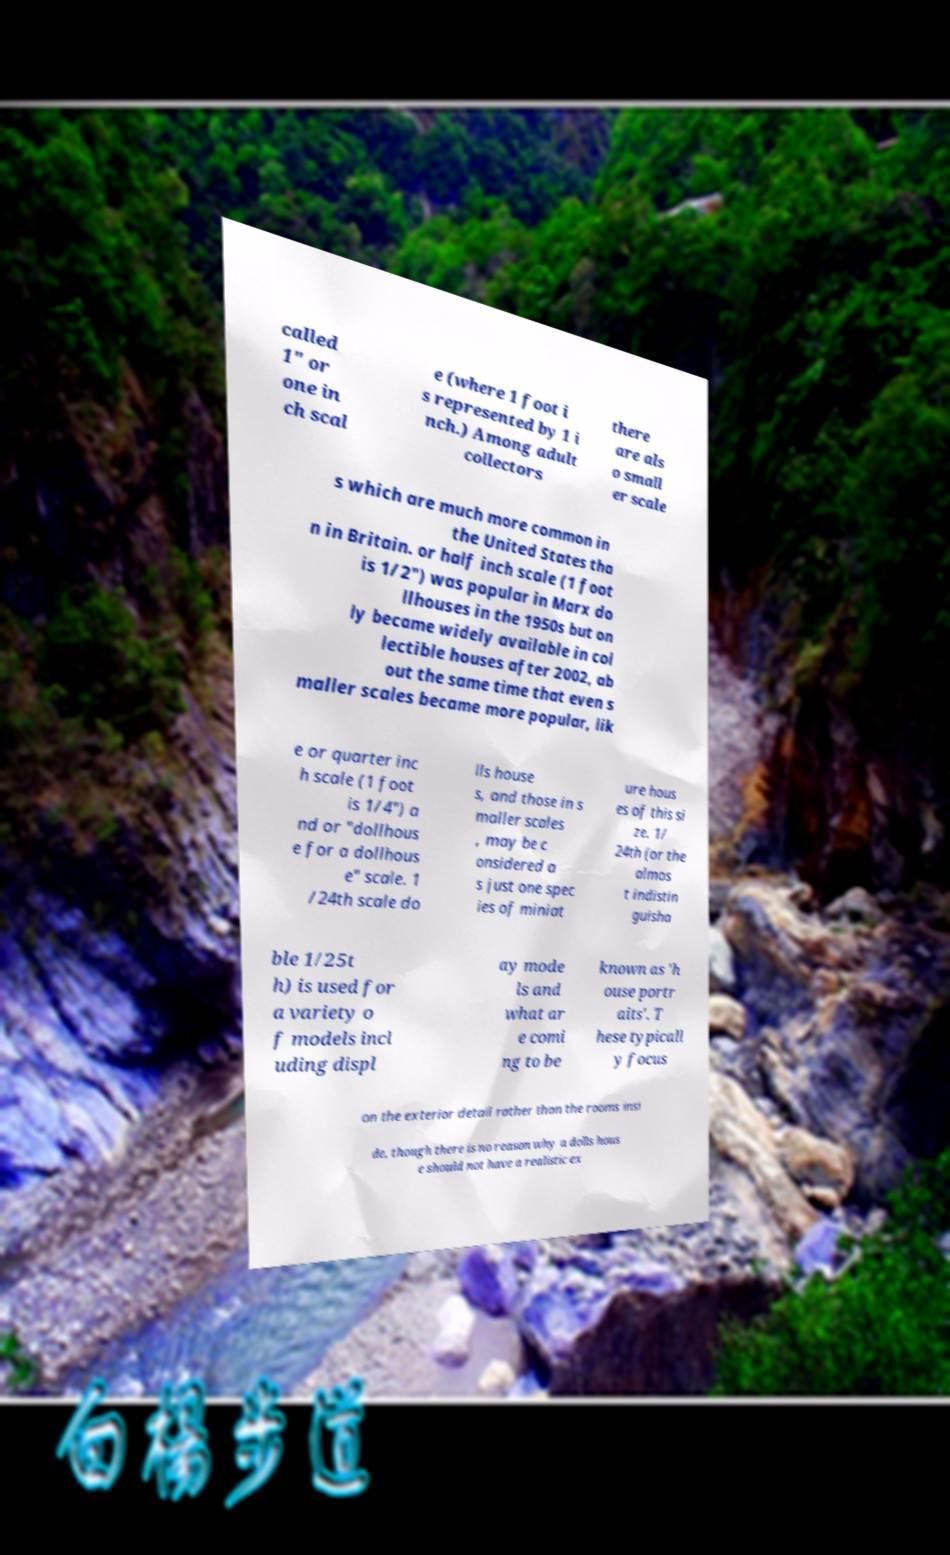I need the written content from this picture converted into text. Can you do that? called 1" or one in ch scal e (where 1 foot i s represented by 1 i nch.) Among adult collectors there are als o small er scale s which are much more common in the United States tha n in Britain. or half inch scale (1 foot is 1/2") was popular in Marx do llhouses in the 1950s but on ly became widely available in col lectible houses after 2002, ab out the same time that even s maller scales became more popular, lik e or quarter inc h scale (1 foot is 1/4") a nd or "dollhous e for a dollhous e" scale. 1 /24th scale do lls house s, and those in s maller scales , may be c onsidered a s just one spec ies of miniat ure hous es of this si ze. 1/ 24th (or the almos t indistin guisha ble 1/25t h) is used for a variety o f models incl uding displ ay mode ls and what ar e comi ng to be known as 'h ouse portr aits'. T hese typicall y focus on the exterior detail rather than the rooms insi de, though there is no reason why a dolls hous e should not have a realistic ex 